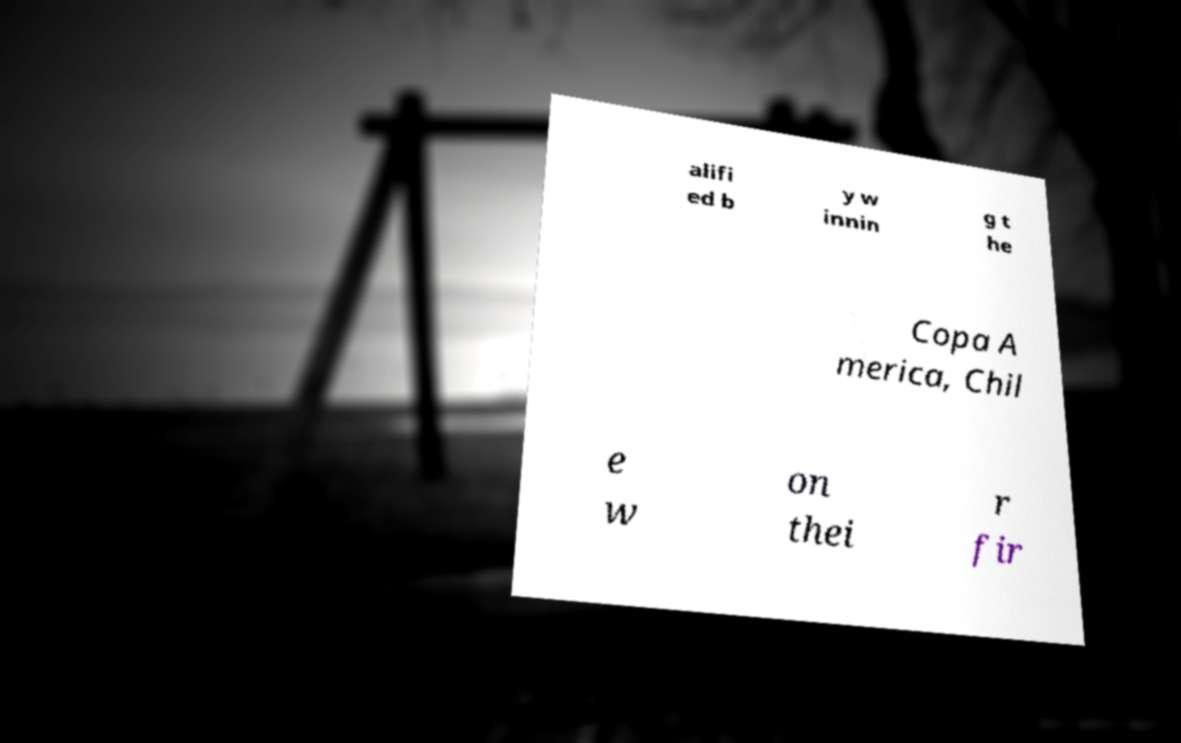Can you accurately transcribe the text from the provided image for me? alifi ed b y w innin g t he Copa A merica, Chil e w on thei r fir 